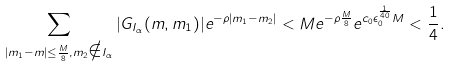<formula> <loc_0><loc_0><loc_500><loc_500>\sum _ { | m _ { 1 } - m | \leq \frac { M } { 8 } , m _ { 2 } \notin I _ { \alpha } } | G _ { I _ { \alpha } } ( m , m _ { 1 } ) | e ^ { - \rho | m _ { 1 } - m _ { 2 } | } < M e ^ { - \rho \frac { M } { 8 } } e ^ { c _ { 0 } \epsilon _ { 0 } ^ { \frac { 1 } { 4 0 } } M } < \frac { 1 } { 4 } .</formula> 